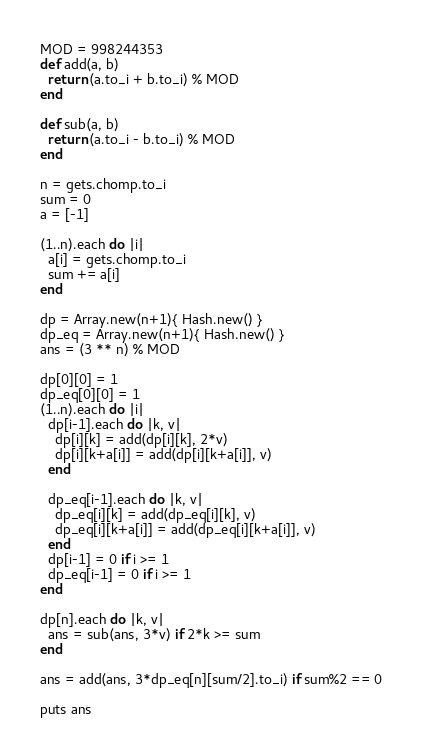Convert code to text. <code><loc_0><loc_0><loc_500><loc_500><_Ruby_>MOD = 998244353
def add(a, b)
  return (a.to_i + b.to_i) % MOD
end

def sub(a, b)
  return (a.to_i - b.to_i) % MOD
end

n = gets.chomp.to_i
sum = 0
a = [-1]

(1..n).each do |i|
  a[i] = gets.chomp.to_i
  sum += a[i]
end

dp = Array.new(n+1){ Hash.new() }
dp_eq = Array.new(n+1){ Hash.new() }
ans = (3 ** n) % MOD

dp[0][0] = 1
dp_eq[0][0] = 1
(1..n).each do |i|
  dp[i-1].each do |k, v|
    dp[i][k] = add(dp[i][k], 2*v)
    dp[i][k+a[i]] = add(dp[i][k+a[i]], v)
  end

  dp_eq[i-1].each do |k, v|
    dp_eq[i][k] = add(dp_eq[i][k], v)
    dp_eq[i][k+a[i]] = add(dp_eq[i][k+a[i]], v)
  end
  dp[i-1] = 0 if i >= 1
  dp_eq[i-1] = 0 if i >= 1
end

dp[n].each do |k, v|
  ans = sub(ans, 3*v) if 2*k >= sum
end

ans = add(ans, 3*dp_eq[n][sum/2].to_i) if sum%2 == 0

puts ans</code> 